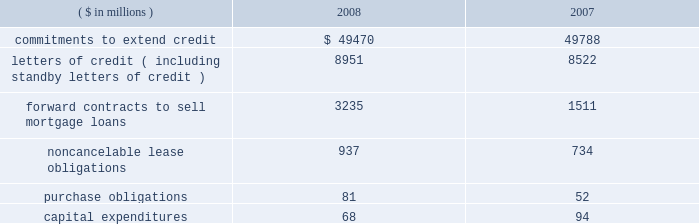Notes to consolidated financial statements fifth third bancorp 81 vii held by the trust vii bear a fixed rate of interest of 8.875% ( 8.875 % ) until may 15 , 2058 .
Thereafter , the notes pay a floating rate at three-month libor plus 500 bp .
The bancorp entered into an interest rate swap to convert $ 275 million of the fixed-rate debt into floating .
At december 31 , 2008 , the rate paid on the swap was 6.05% ( 6.05 % ) .
The jsn vii may be redeemed at the option of the bancorp on or after may 15 , 2013 , or in certain other limited circumstances , at a redemption price of 100% ( 100 % ) of the principal amount plus accrued but unpaid interest .
All redemptions are subject to certain conditions and generally require approval by the federal reserve board .
Subsidiary long-term borrowings the senior fixed-rate bank notes due from 2009 to 2019 are the obligations of a subsidiary bank .
The maturities of the face value of the senior fixed-rate bank notes are as follows : $ 36 million in 2009 , $ 800 million in 2010 and $ 275 million in 2019 .
The bancorp entered into interest rate swaps to convert $ 1.1 billion of the fixed-rate debt into floating rates .
At december 31 , 2008 , the rates paid on these swaps were 2.19% ( 2.19 % ) on $ 800 million and 2.20% ( 2.20 % ) on $ 275 million .
In august 2008 , $ 500 million of senior fixed-rate bank notes issued in july of 2003 matured and were paid .
These long-term bank notes were issued to third-party investors at a fixed rate of 3.375% ( 3.375 % ) .
The senior floating-rate bank notes due in 2013 are the obligations of a subsidiary bank .
The notes pay a floating rate at three-month libor plus 11 bp .
The senior extendable notes consist of $ 797 million that currently pay interest at three-month libor plus 4 bp and $ 400 million that pay at the federal funds open rate plus 12 bp .
The subordinated fixed-rate bank notes due in 2015 are the obligations of a subsidiary bank .
The bancorp entered into interest rate swaps to convert the fixed-rate debt into floating rate .
At december 31 , 2008 , the weighted-average rate paid on the swaps was 3.29% ( 3.29 % ) .
The junior subordinated floating-rate bank notes due in 2032 and 2033 were assumed by a bancorp subsidiary as part of the acquisition of crown in november 2007 .
Two of the notes pay floating at three-month libor plus 310 and 325 bp .
The third note pays floating at six-month libor plus 370 bp .
The three-month libor plus 290 bp and the three-month libor plus 279 bp junior subordinated debentures due in 2033 and 2034 , respectively , were assumed by a subsidiary of the bancorp in connection with the acquisition of first national bank .
The obligations were issued to fnb statutory trusts i and ii , respectively .
The junior subordinated floating-rate bank notes due in 2035 were assumed by a bancorp subsidiary as part of the acquisition of first charter in may 2008 .
The obligations were issued to first charter capital trust i and ii , respectively .
The notes of first charter capital trust i and ii pay floating at three-month libor plus 169 bp and 142 bp , respectively .
The bancorp has fully and unconditionally guaranteed all obligations under the acquired trust preferred securities .
At december 31 , 2008 , fhlb advances have rates ranging from 0% ( 0 % ) to 8.34% ( 8.34 % ) , with interest payable monthly .
The advances are secured by certain residential mortgage loans and securities totaling $ 8.6 billion .
At december 31 , 2008 , $ 2.5 billion of fhlb advances are floating rate .
The bancorp has interest rate caps , with a notional of $ 1.5 billion , held against its fhlb advance borrowings .
The $ 3.6 billion in advances mature as follows : $ 1.5 billion in 2009 , $ 1 million in 2010 , $ 2 million in 2011 , $ 1 billion in 2012 and $ 1.1 billion in 2013 and thereafter .
Medium-term senior notes and subordinated bank notes with maturities ranging from one year to 30 years can be issued by two subsidiary banks , of which $ 3.8 billion was outstanding at december 31 , 2008 with $ 16.2 billion available for future issuance .
There were no other medium-term senior notes outstanding on either of the two subsidiary banks as of december 31 , 2008 .
15 .
Commitments , contingent liabilities and guarantees the bancorp , in the normal course of business , enters into financial instruments and various agreements to meet the financing needs of its customers .
The bancorp also enters into certain transactions and agreements to manage its interest rate and prepayment risks , provide funding , equipment and locations for its operations and invest in its communities .
These instruments and agreements involve , to varying degrees , elements of credit risk , counterparty risk and market risk in excess of the amounts recognized in the bancorp 2019s consolidated balance sheets .
Creditworthiness for all instruments and agreements is evaluated on a case-by-case basis in accordance with the bancorp 2019s credit policies .
The bancorp 2019s significant commitments , contingent liabilities and guarantees in excess of the amounts recognized in the consolidated balance sheets are summarized as follows : commitments the bancorp has certain commitments to make future payments under contracts .
A summary of significant commitments at december 31: .
Commitments to extend credit are agreements to lend , typically having fixed expiration dates or other termination clauses that may require payment of a fee .
Since many of the commitments to extend credit may expire without being drawn upon , the total commitment amounts do not necessarily represent future cash flow requirements .
The bancorp is exposed to credit risk in the event of nonperformance for the amount of the contract .
Fixed-rate commitments are also subject to market risk resulting from fluctuations in interest rates and the bancorp 2019s exposure is limited to the replacement value of those commitments .
As of december 31 , 2008 and 2007 , the bancorp had a reserve for unfunded commitments totaling $ 195 million and $ 95 million , respectively , included in other liabilities in the consolidated balance sheets .
Standby and commercial letters of credit are conditional commitments issued to guarantee the performance of a customer to a third party .
At december 31 , 2008 , approximately $ 3.3 billion of letters of credit expire within one year ( including $ 57 million issued on behalf of commercial customers to facilitate trade payments in dollars and foreign currencies ) , $ 5.3 billion expire between one to five years and $ 0.4 billion expire thereafter .
Standby letters of credit are considered guarantees in accordance with fasb interpretation no .
45 , 201cguarantor 2019s accounting and disclosure requirements for guarantees , including indirect guarantees of indebtedness of others 201d ( fin 45 ) .
At december 31 , 2008 , the reserve related to these standby letters of credit was $ 3 million .
Approximately 66% ( 66 % ) and 70% ( 70 % ) of the total standby letters of credit were secured as of december 31 , 2008 and 2007 , respectively .
In the event of nonperformance by the customers , the bancorp has rights to the underlying collateral , which can include commercial real estate , physical plant and property , inventory , receivables , cash and marketable securities .
The bancorp monitors the credit risk associated with the standby letters of credit using the same dual risk rating system utilized for .
What was the total amount of unfunded commitments in millions as of the end of 2008 and 2007? 
Computations: (195 + 95)
Answer: 290.0. 